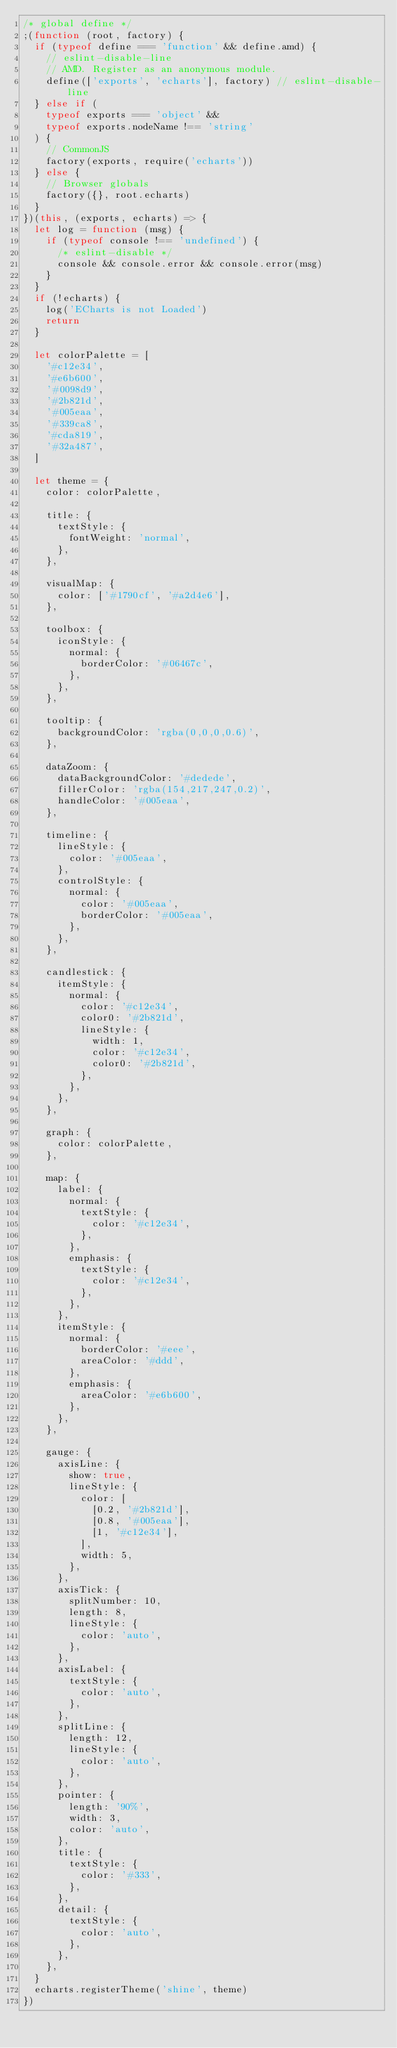Convert code to text. <code><loc_0><loc_0><loc_500><loc_500><_JavaScript_>/* global define */
;(function (root, factory) {
  if (typeof define === 'function' && define.amd) {
    // eslint-disable-line
    // AMD. Register as an anonymous module.
    define(['exports', 'echarts'], factory) // eslint-disable-line
  } else if (
    typeof exports === 'object' &&
    typeof exports.nodeName !== 'string'
  ) {
    // CommonJS
    factory(exports, require('echarts'))
  } else {
    // Browser globals
    factory({}, root.echarts)
  }
})(this, (exports, echarts) => {
  let log = function (msg) {
    if (typeof console !== 'undefined') {
      /* eslint-disable */
      console && console.error && console.error(msg)
    }
  }
  if (!echarts) {
    log('ECharts is not Loaded')
    return
  }

  let colorPalette = [
    '#c12e34',
    '#e6b600',
    '#0098d9',
    '#2b821d',
    '#005eaa',
    '#339ca8',
    '#cda819',
    '#32a487',
  ]

  let theme = {
    color: colorPalette,

    title: {
      textStyle: {
        fontWeight: 'normal',
      },
    },

    visualMap: {
      color: ['#1790cf', '#a2d4e6'],
    },

    toolbox: {
      iconStyle: {
        normal: {
          borderColor: '#06467c',
        },
      },
    },

    tooltip: {
      backgroundColor: 'rgba(0,0,0,0.6)',
    },

    dataZoom: {
      dataBackgroundColor: '#dedede',
      fillerColor: 'rgba(154,217,247,0.2)',
      handleColor: '#005eaa',
    },

    timeline: {
      lineStyle: {
        color: '#005eaa',
      },
      controlStyle: {
        normal: {
          color: '#005eaa',
          borderColor: '#005eaa',
        },
      },
    },

    candlestick: {
      itemStyle: {
        normal: {
          color: '#c12e34',
          color0: '#2b821d',
          lineStyle: {
            width: 1,
            color: '#c12e34',
            color0: '#2b821d',
          },
        },
      },
    },

    graph: {
      color: colorPalette,
    },

    map: {
      label: {
        normal: {
          textStyle: {
            color: '#c12e34',
          },
        },
        emphasis: {
          textStyle: {
            color: '#c12e34',
          },
        },
      },
      itemStyle: {
        normal: {
          borderColor: '#eee',
          areaColor: '#ddd',
        },
        emphasis: {
          areaColor: '#e6b600',
        },
      },
    },

    gauge: {
      axisLine: {
        show: true,
        lineStyle: {
          color: [
            [0.2, '#2b821d'],
            [0.8, '#005eaa'],
            [1, '#c12e34'],
          ],
          width: 5,
        },
      },
      axisTick: {
        splitNumber: 10,
        length: 8,
        lineStyle: {
          color: 'auto',
        },
      },
      axisLabel: {
        textStyle: {
          color: 'auto',
        },
      },
      splitLine: {
        length: 12,
        lineStyle: {
          color: 'auto',
        },
      },
      pointer: {
        length: '90%',
        width: 3,
        color: 'auto',
      },
      title: {
        textStyle: {
          color: '#333',
        },
      },
      detail: {
        textStyle: {
          color: 'auto',
        },
      },
    },
  }
  echarts.registerTheme('shine', theme)
})
</code> 